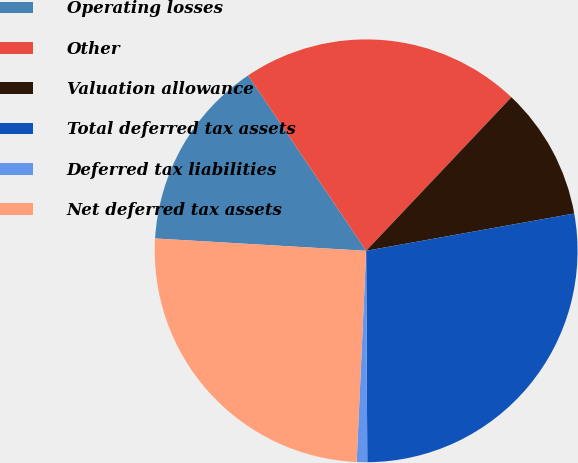Convert chart. <chart><loc_0><loc_0><loc_500><loc_500><pie_chart><fcel>Operating losses<fcel>Other<fcel>Valuation allowance<fcel>Total deferred tax assets<fcel>Deferred tax liabilities<fcel>Net deferred tax assets<nl><fcel>14.64%<fcel>21.49%<fcel>10.12%<fcel>27.74%<fcel>0.8%<fcel>25.22%<nl></chart> 